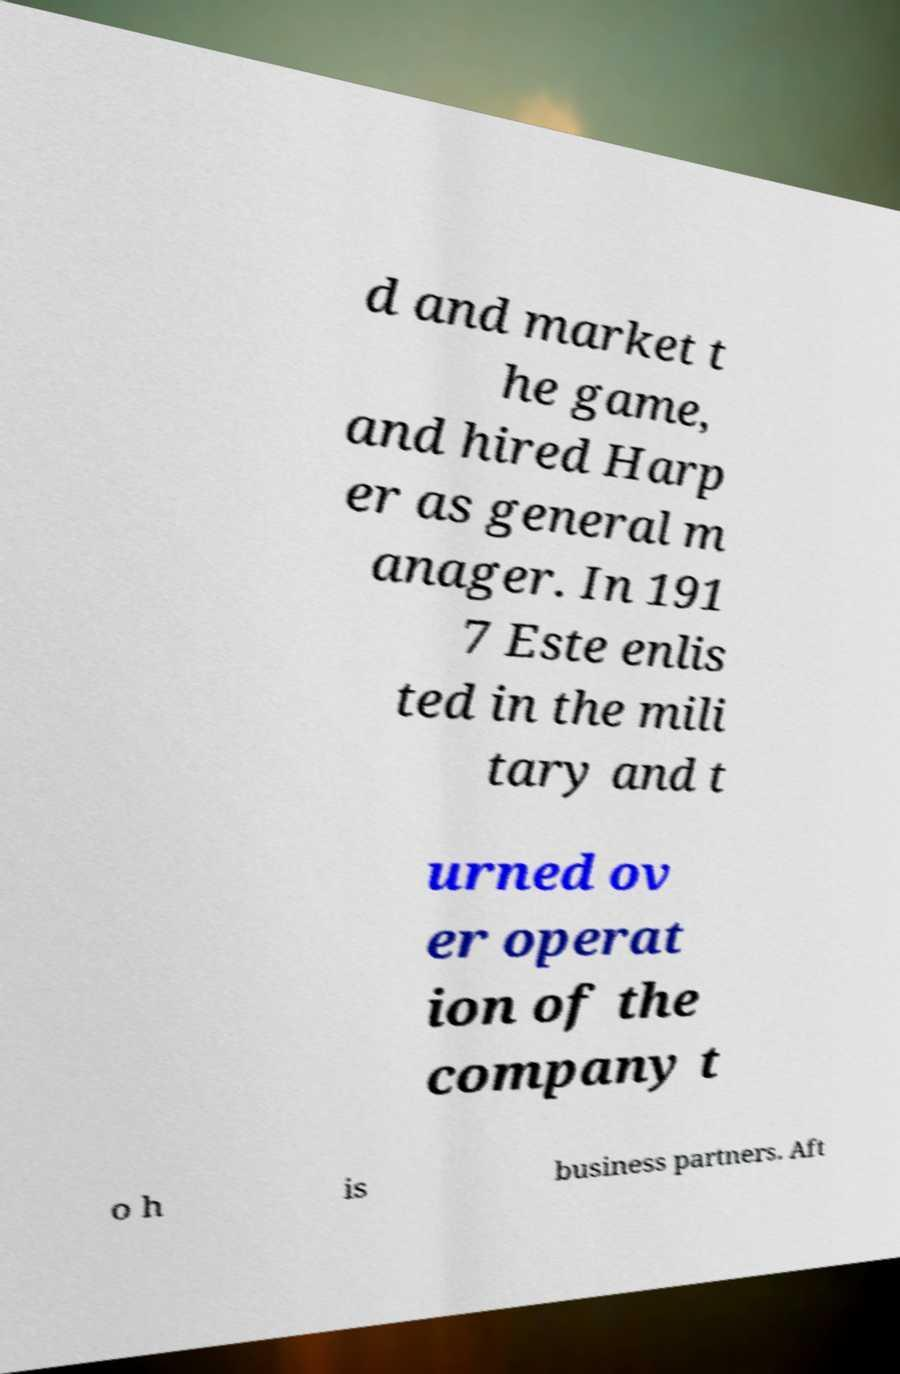I need the written content from this picture converted into text. Can you do that? d and market t he game, and hired Harp er as general m anager. In 191 7 Este enlis ted in the mili tary and t urned ov er operat ion of the company t o h is business partners. Aft 